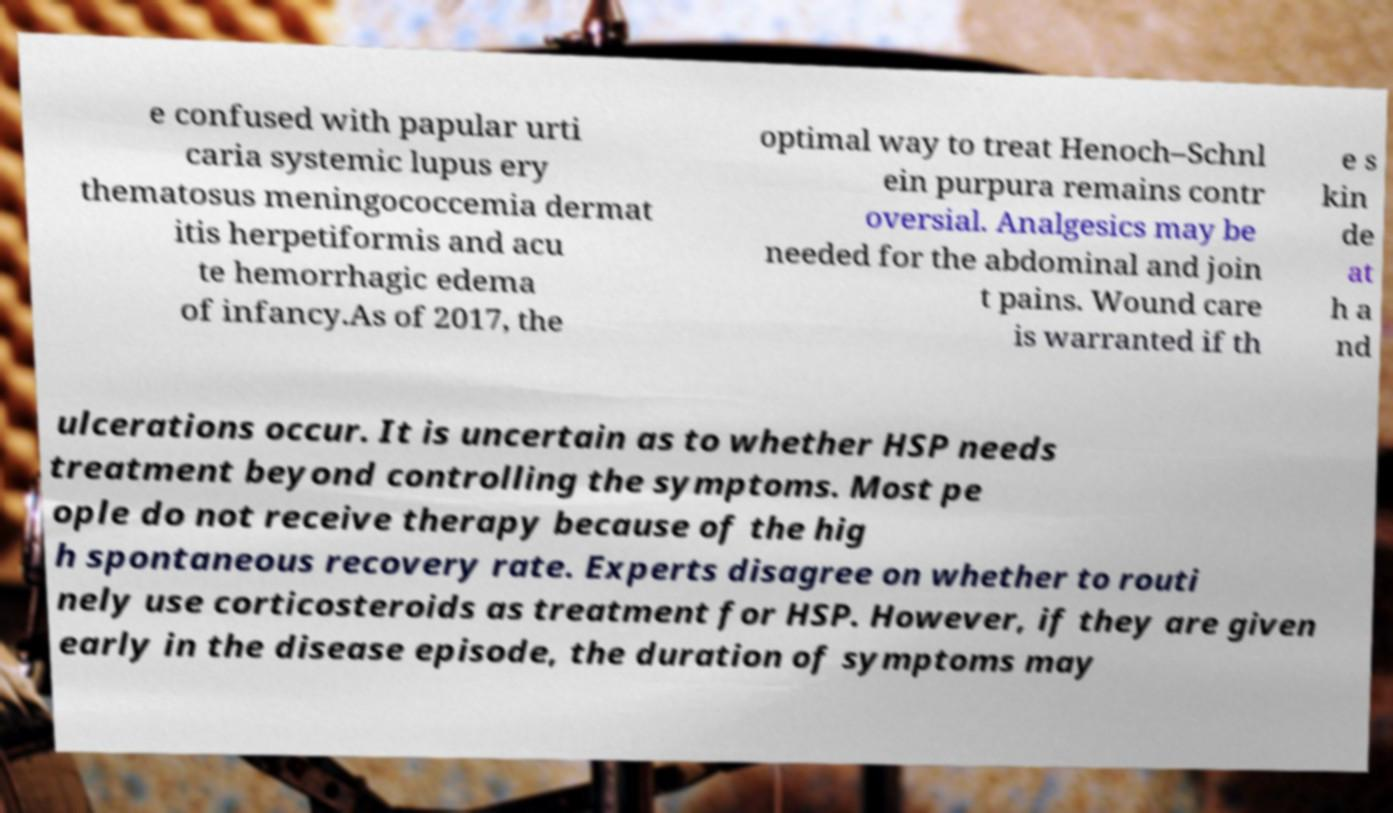Can you accurately transcribe the text from the provided image for me? e confused with papular urti caria systemic lupus ery thematosus meningococcemia dermat itis herpetiformis and acu te hemorrhagic edema of infancy.As of 2017, the optimal way to treat Henoch–Schnl ein purpura remains contr oversial. Analgesics may be needed for the abdominal and join t pains. Wound care is warranted if th e s kin de at h a nd ulcerations occur. It is uncertain as to whether HSP needs treatment beyond controlling the symptoms. Most pe ople do not receive therapy because of the hig h spontaneous recovery rate. Experts disagree on whether to routi nely use corticosteroids as treatment for HSP. However, if they are given early in the disease episode, the duration of symptoms may 